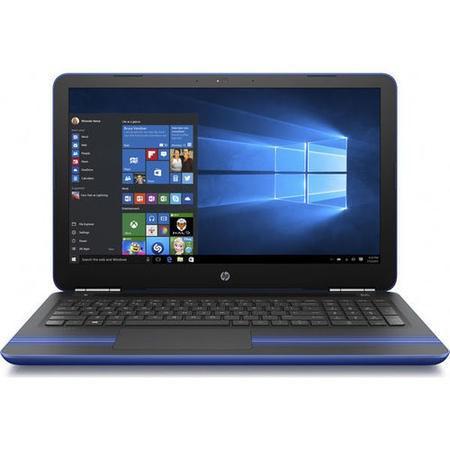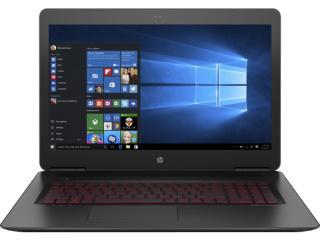The first image is the image on the left, the second image is the image on the right. Assess this claim about the two images: "At least one laptop is pictured against a black background.". Correct or not? Answer yes or no. No. 